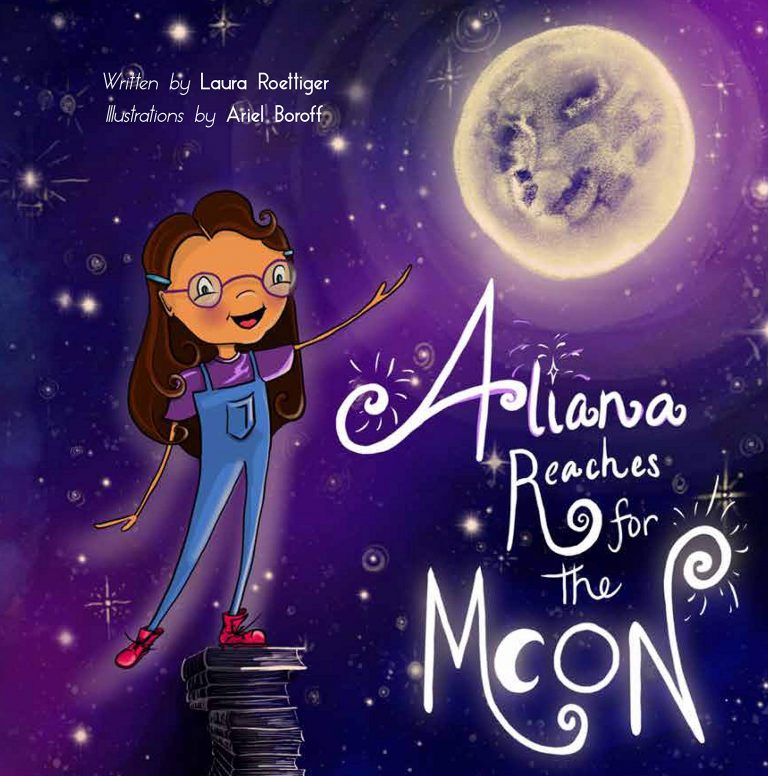Imagine a scenario where the girl finally reaches the moon. What do you think she would find there? If Aliana were to finally reach the moon, she might find a surreal landscape filled with more possibilities and adventures. Perhaps the moon is not barren but is a vibrant place with lunar gardens, shimmering moon flowers, and pools of liquid silver reflecting the Earth. There might be friendly lunar inhabitants who share their wisdom and stories from a different world. This fantastical vision reinforces the idea that dreams, when pursued, lead to even more exciting and enriching journeys. Such scenarios spark the imagination and underscore the boundless possibilities that come with following one's dreams. 